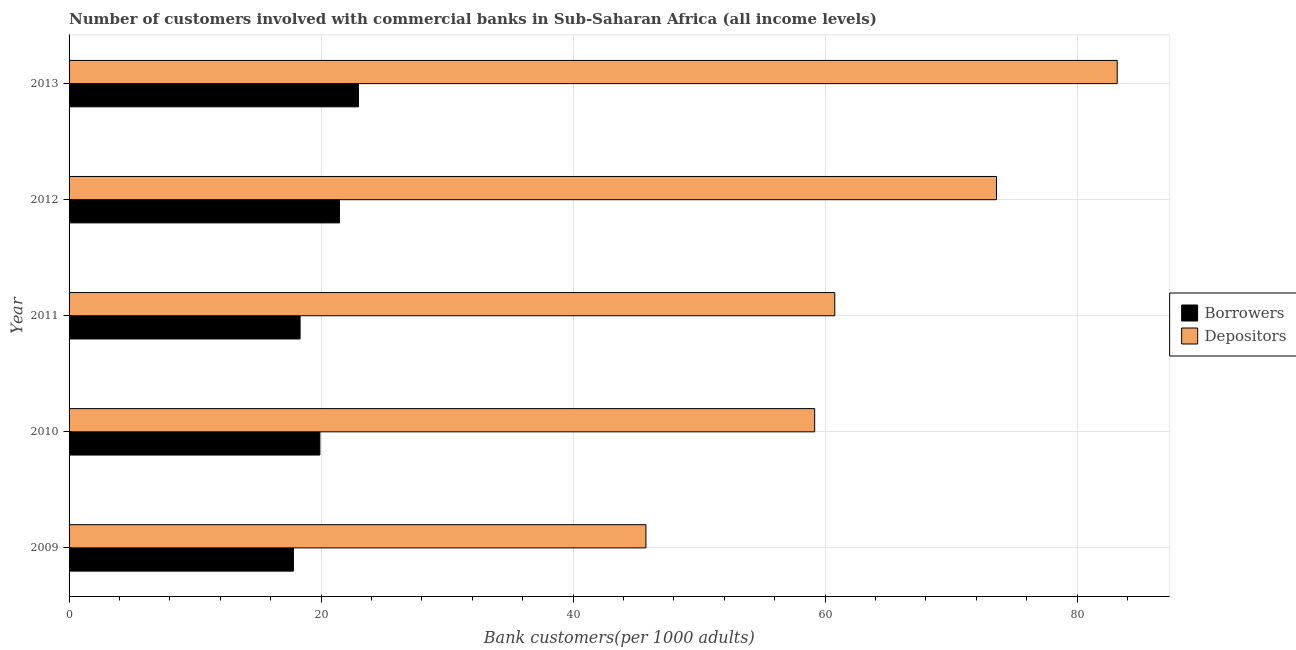How many groups of bars are there?
Provide a succinct answer. 5. How many bars are there on the 1st tick from the top?
Ensure brevity in your answer.  2. In how many cases, is the number of bars for a given year not equal to the number of legend labels?
Provide a short and direct response. 0. What is the number of borrowers in 2010?
Offer a terse response. 19.9. Across all years, what is the maximum number of depositors?
Offer a terse response. 83.18. Across all years, what is the minimum number of borrowers?
Your answer should be very brief. 17.81. What is the total number of depositors in the graph?
Offer a very short reply. 322.48. What is the difference between the number of depositors in 2012 and that in 2013?
Give a very brief answer. -9.58. What is the difference between the number of depositors in 2009 and the number of borrowers in 2011?
Ensure brevity in your answer.  27.44. What is the average number of depositors per year?
Your answer should be compact. 64.5. In the year 2009, what is the difference between the number of borrowers and number of depositors?
Give a very brief answer. -27.97. What is the ratio of the number of borrowers in 2009 to that in 2012?
Offer a very short reply. 0.83. Is the number of depositors in 2011 less than that in 2013?
Give a very brief answer. Yes. Is the difference between the number of depositors in 2009 and 2012 greater than the difference between the number of borrowers in 2009 and 2012?
Offer a terse response. No. What is the difference between the highest and the second highest number of depositors?
Keep it short and to the point. 9.58. What is the difference between the highest and the lowest number of depositors?
Your answer should be very brief. 37.4. In how many years, is the number of depositors greater than the average number of depositors taken over all years?
Give a very brief answer. 2. What does the 1st bar from the top in 2011 represents?
Ensure brevity in your answer.  Depositors. What does the 2nd bar from the bottom in 2013 represents?
Give a very brief answer. Depositors. How many years are there in the graph?
Keep it short and to the point. 5. Does the graph contain grids?
Your response must be concise. Yes. How many legend labels are there?
Your answer should be very brief. 2. How are the legend labels stacked?
Give a very brief answer. Vertical. What is the title of the graph?
Your response must be concise. Number of customers involved with commercial banks in Sub-Saharan Africa (all income levels). Does "Residents" appear as one of the legend labels in the graph?
Provide a short and direct response. No. What is the label or title of the X-axis?
Give a very brief answer. Bank customers(per 1000 adults). What is the Bank customers(per 1000 adults) in Borrowers in 2009?
Your answer should be very brief. 17.81. What is the Bank customers(per 1000 adults) of Depositors in 2009?
Your answer should be very brief. 45.78. What is the Bank customers(per 1000 adults) of Borrowers in 2010?
Your response must be concise. 19.9. What is the Bank customers(per 1000 adults) in Depositors in 2010?
Offer a very short reply. 59.17. What is the Bank customers(per 1000 adults) of Borrowers in 2011?
Ensure brevity in your answer.  18.33. What is the Bank customers(per 1000 adults) in Depositors in 2011?
Your answer should be very brief. 60.76. What is the Bank customers(per 1000 adults) in Borrowers in 2012?
Your response must be concise. 21.46. What is the Bank customers(per 1000 adults) in Depositors in 2012?
Your answer should be very brief. 73.6. What is the Bank customers(per 1000 adults) of Borrowers in 2013?
Keep it short and to the point. 22.96. What is the Bank customers(per 1000 adults) of Depositors in 2013?
Your answer should be compact. 83.18. Across all years, what is the maximum Bank customers(per 1000 adults) of Borrowers?
Keep it short and to the point. 22.96. Across all years, what is the maximum Bank customers(per 1000 adults) in Depositors?
Your answer should be compact. 83.18. Across all years, what is the minimum Bank customers(per 1000 adults) of Borrowers?
Your answer should be compact. 17.81. Across all years, what is the minimum Bank customers(per 1000 adults) in Depositors?
Your answer should be compact. 45.78. What is the total Bank customers(per 1000 adults) of Borrowers in the graph?
Your answer should be very brief. 100.46. What is the total Bank customers(per 1000 adults) of Depositors in the graph?
Provide a succinct answer. 322.48. What is the difference between the Bank customers(per 1000 adults) of Borrowers in 2009 and that in 2010?
Provide a short and direct response. -2.1. What is the difference between the Bank customers(per 1000 adults) of Depositors in 2009 and that in 2010?
Your answer should be compact. -13.39. What is the difference between the Bank customers(per 1000 adults) of Borrowers in 2009 and that in 2011?
Make the answer very short. -0.53. What is the difference between the Bank customers(per 1000 adults) of Depositors in 2009 and that in 2011?
Provide a succinct answer. -14.99. What is the difference between the Bank customers(per 1000 adults) of Borrowers in 2009 and that in 2012?
Keep it short and to the point. -3.65. What is the difference between the Bank customers(per 1000 adults) in Depositors in 2009 and that in 2012?
Offer a terse response. -27.82. What is the difference between the Bank customers(per 1000 adults) of Borrowers in 2009 and that in 2013?
Offer a very short reply. -5.16. What is the difference between the Bank customers(per 1000 adults) of Depositors in 2009 and that in 2013?
Keep it short and to the point. -37.4. What is the difference between the Bank customers(per 1000 adults) of Borrowers in 2010 and that in 2011?
Your answer should be compact. 1.57. What is the difference between the Bank customers(per 1000 adults) in Depositors in 2010 and that in 2011?
Your response must be concise. -1.59. What is the difference between the Bank customers(per 1000 adults) of Borrowers in 2010 and that in 2012?
Make the answer very short. -1.56. What is the difference between the Bank customers(per 1000 adults) of Depositors in 2010 and that in 2012?
Ensure brevity in your answer.  -14.43. What is the difference between the Bank customers(per 1000 adults) of Borrowers in 2010 and that in 2013?
Offer a terse response. -3.06. What is the difference between the Bank customers(per 1000 adults) in Depositors in 2010 and that in 2013?
Ensure brevity in your answer.  -24.01. What is the difference between the Bank customers(per 1000 adults) in Borrowers in 2011 and that in 2012?
Provide a short and direct response. -3.13. What is the difference between the Bank customers(per 1000 adults) of Depositors in 2011 and that in 2012?
Your response must be concise. -12.83. What is the difference between the Bank customers(per 1000 adults) in Borrowers in 2011 and that in 2013?
Provide a short and direct response. -4.63. What is the difference between the Bank customers(per 1000 adults) of Depositors in 2011 and that in 2013?
Provide a succinct answer. -22.41. What is the difference between the Bank customers(per 1000 adults) of Borrowers in 2012 and that in 2013?
Give a very brief answer. -1.5. What is the difference between the Bank customers(per 1000 adults) in Depositors in 2012 and that in 2013?
Give a very brief answer. -9.58. What is the difference between the Bank customers(per 1000 adults) of Borrowers in 2009 and the Bank customers(per 1000 adults) of Depositors in 2010?
Your response must be concise. -41.36. What is the difference between the Bank customers(per 1000 adults) in Borrowers in 2009 and the Bank customers(per 1000 adults) in Depositors in 2011?
Provide a succinct answer. -42.96. What is the difference between the Bank customers(per 1000 adults) of Borrowers in 2009 and the Bank customers(per 1000 adults) of Depositors in 2012?
Ensure brevity in your answer.  -55.79. What is the difference between the Bank customers(per 1000 adults) of Borrowers in 2009 and the Bank customers(per 1000 adults) of Depositors in 2013?
Offer a terse response. -65.37. What is the difference between the Bank customers(per 1000 adults) of Borrowers in 2010 and the Bank customers(per 1000 adults) of Depositors in 2011?
Give a very brief answer. -40.86. What is the difference between the Bank customers(per 1000 adults) in Borrowers in 2010 and the Bank customers(per 1000 adults) in Depositors in 2012?
Give a very brief answer. -53.69. What is the difference between the Bank customers(per 1000 adults) of Borrowers in 2010 and the Bank customers(per 1000 adults) of Depositors in 2013?
Offer a terse response. -63.27. What is the difference between the Bank customers(per 1000 adults) of Borrowers in 2011 and the Bank customers(per 1000 adults) of Depositors in 2012?
Your answer should be very brief. -55.26. What is the difference between the Bank customers(per 1000 adults) in Borrowers in 2011 and the Bank customers(per 1000 adults) in Depositors in 2013?
Your response must be concise. -64.84. What is the difference between the Bank customers(per 1000 adults) of Borrowers in 2012 and the Bank customers(per 1000 adults) of Depositors in 2013?
Your answer should be compact. -61.72. What is the average Bank customers(per 1000 adults) in Borrowers per year?
Give a very brief answer. 20.09. What is the average Bank customers(per 1000 adults) in Depositors per year?
Provide a short and direct response. 64.5. In the year 2009, what is the difference between the Bank customers(per 1000 adults) in Borrowers and Bank customers(per 1000 adults) in Depositors?
Provide a short and direct response. -27.97. In the year 2010, what is the difference between the Bank customers(per 1000 adults) in Borrowers and Bank customers(per 1000 adults) in Depositors?
Ensure brevity in your answer.  -39.26. In the year 2011, what is the difference between the Bank customers(per 1000 adults) in Borrowers and Bank customers(per 1000 adults) in Depositors?
Your response must be concise. -42.43. In the year 2012, what is the difference between the Bank customers(per 1000 adults) of Borrowers and Bank customers(per 1000 adults) of Depositors?
Give a very brief answer. -52.14. In the year 2013, what is the difference between the Bank customers(per 1000 adults) of Borrowers and Bank customers(per 1000 adults) of Depositors?
Your answer should be compact. -60.21. What is the ratio of the Bank customers(per 1000 adults) in Borrowers in 2009 to that in 2010?
Your answer should be very brief. 0.89. What is the ratio of the Bank customers(per 1000 adults) in Depositors in 2009 to that in 2010?
Offer a terse response. 0.77. What is the ratio of the Bank customers(per 1000 adults) of Borrowers in 2009 to that in 2011?
Provide a succinct answer. 0.97. What is the ratio of the Bank customers(per 1000 adults) of Depositors in 2009 to that in 2011?
Your response must be concise. 0.75. What is the ratio of the Bank customers(per 1000 adults) in Borrowers in 2009 to that in 2012?
Give a very brief answer. 0.83. What is the ratio of the Bank customers(per 1000 adults) in Depositors in 2009 to that in 2012?
Offer a terse response. 0.62. What is the ratio of the Bank customers(per 1000 adults) in Borrowers in 2009 to that in 2013?
Give a very brief answer. 0.78. What is the ratio of the Bank customers(per 1000 adults) of Depositors in 2009 to that in 2013?
Provide a succinct answer. 0.55. What is the ratio of the Bank customers(per 1000 adults) in Borrowers in 2010 to that in 2011?
Your answer should be very brief. 1.09. What is the ratio of the Bank customers(per 1000 adults) in Depositors in 2010 to that in 2011?
Provide a short and direct response. 0.97. What is the ratio of the Bank customers(per 1000 adults) in Borrowers in 2010 to that in 2012?
Offer a terse response. 0.93. What is the ratio of the Bank customers(per 1000 adults) of Depositors in 2010 to that in 2012?
Provide a succinct answer. 0.8. What is the ratio of the Bank customers(per 1000 adults) in Borrowers in 2010 to that in 2013?
Ensure brevity in your answer.  0.87. What is the ratio of the Bank customers(per 1000 adults) of Depositors in 2010 to that in 2013?
Give a very brief answer. 0.71. What is the ratio of the Bank customers(per 1000 adults) of Borrowers in 2011 to that in 2012?
Your response must be concise. 0.85. What is the ratio of the Bank customers(per 1000 adults) of Depositors in 2011 to that in 2012?
Ensure brevity in your answer.  0.83. What is the ratio of the Bank customers(per 1000 adults) in Borrowers in 2011 to that in 2013?
Your answer should be very brief. 0.8. What is the ratio of the Bank customers(per 1000 adults) of Depositors in 2011 to that in 2013?
Make the answer very short. 0.73. What is the ratio of the Bank customers(per 1000 adults) in Borrowers in 2012 to that in 2013?
Offer a very short reply. 0.93. What is the ratio of the Bank customers(per 1000 adults) of Depositors in 2012 to that in 2013?
Keep it short and to the point. 0.88. What is the difference between the highest and the second highest Bank customers(per 1000 adults) in Borrowers?
Offer a very short reply. 1.5. What is the difference between the highest and the second highest Bank customers(per 1000 adults) in Depositors?
Offer a very short reply. 9.58. What is the difference between the highest and the lowest Bank customers(per 1000 adults) of Borrowers?
Provide a short and direct response. 5.16. What is the difference between the highest and the lowest Bank customers(per 1000 adults) in Depositors?
Your response must be concise. 37.4. 